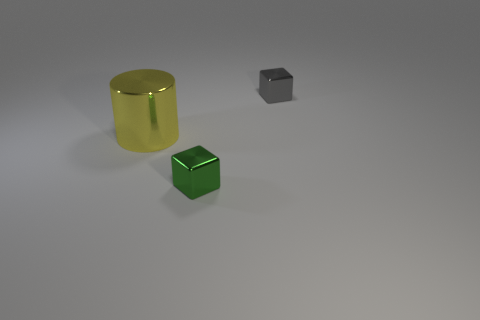Add 3 green metallic objects. How many objects exist? 6 Subtract all cubes. How many objects are left? 1 Subtract all big yellow shiny cylinders. Subtract all green objects. How many objects are left? 1 Add 2 green shiny objects. How many green shiny objects are left? 3 Add 1 tiny cubes. How many tiny cubes exist? 3 Subtract 0 blue cylinders. How many objects are left? 3 